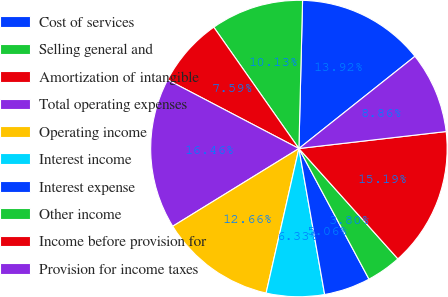Convert chart. <chart><loc_0><loc_0><loc_500><loc_500><pie_chart><fcel>Cost of services<fcel>Selling general and<fcel>Amortization of intangible<fcel>Total operating expenses<fcel>Operating income<fcel>Interest income<fcel>Interest expense<fcel>Other income<fcel>Income before provision for<fcel>Provision for income taxes<nl><fcel>13.92%<fcel>10.13%<fcel>7.59%<fcel>16.46%<fcel>12.66%<fcel>6.33%<fcel>5.06%<fcel>3.8%<fcel>15.19%<fcel>8.86%<nl></chart> 